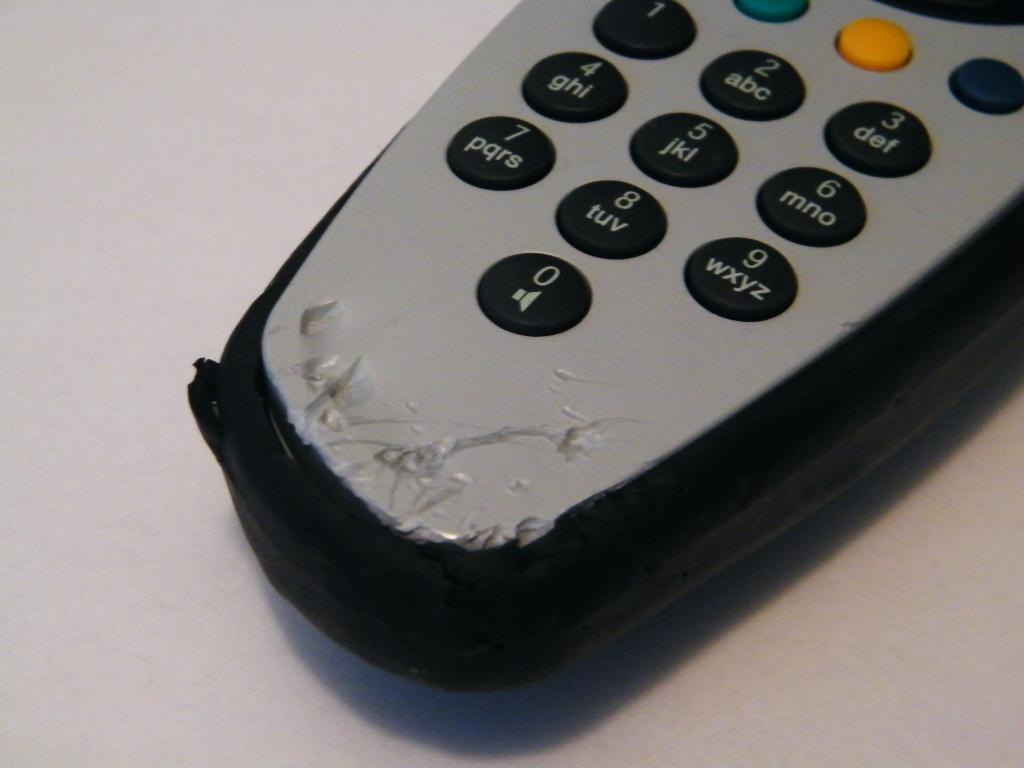<image>
Share a concise interpretation of the image provided. Messed up remote controller with a button that says "pqrs". 